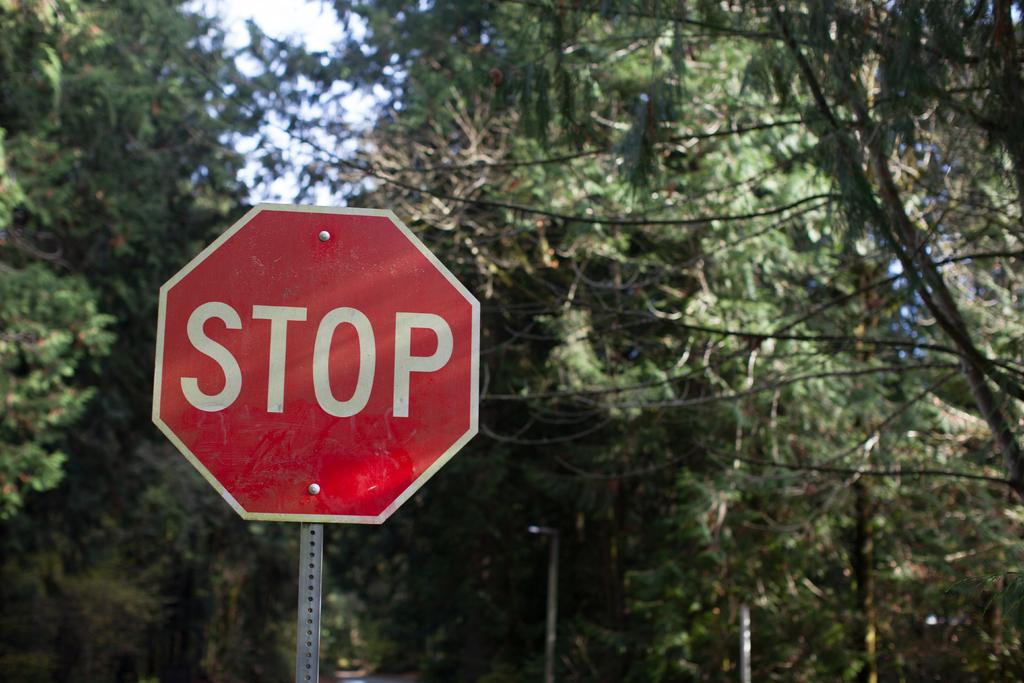<image>
Relay a brief, clear account of the picture shown. Stop sign with lots of trees around it, there is sunlight at the top. 